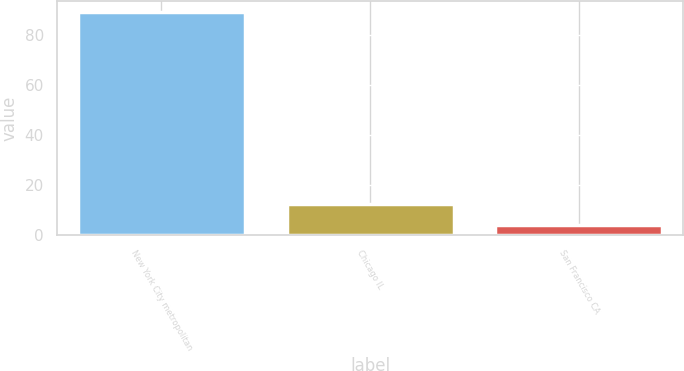Convert chart to OTSL. <chart><loc_0><loc_0><loc_500><loc_500><bar_chart><fcel>New York City metropolitan<fcel>Chicago IL<fcel>San Francisco CA<nl><fcel>89<fcel>12.5<fcel>4<nl></chart> 